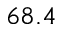<formula> <loc_0><loc_0><loc_500><loc_500>6 8 . 4</formula> 